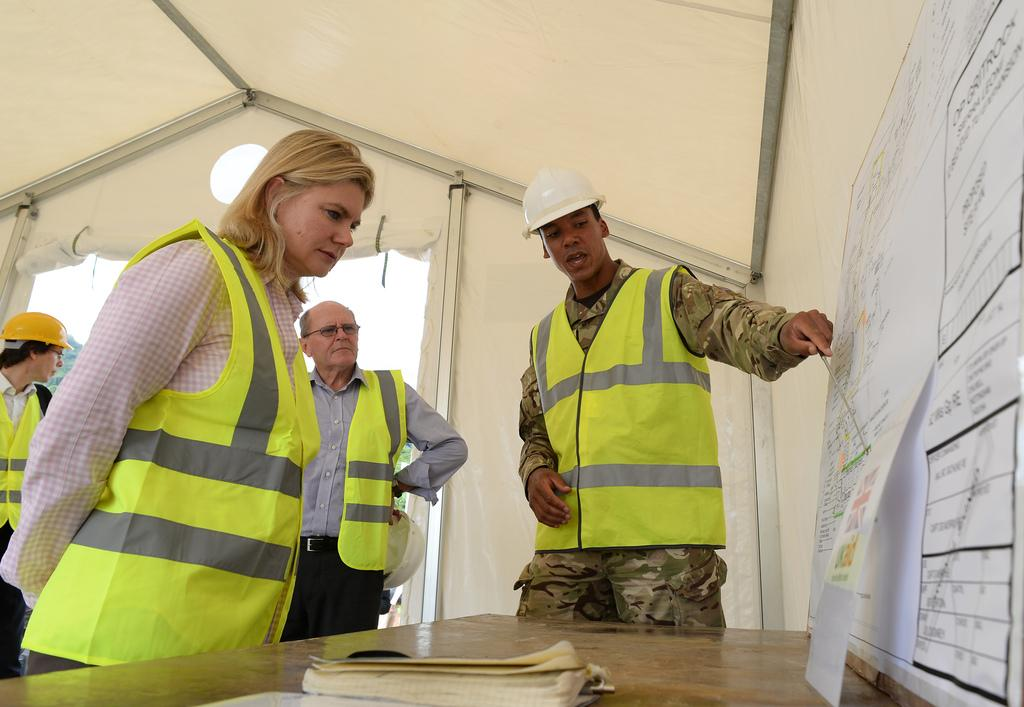How many people are in the group visible in the image? There is a group of people in the image, but the exact number is not specified. What are some people in the group wearing? Some people in the group are wearing helmets. What can be seen on the table in the image? There are papers and a book on the table in the image. Where is the group of people located? The group of people is inside a tent. How many boats are visible in the image? There are no boats present in the image. What rule is being enforced by the group of people in the image? There is no indication of a rule being enforced in the image. 